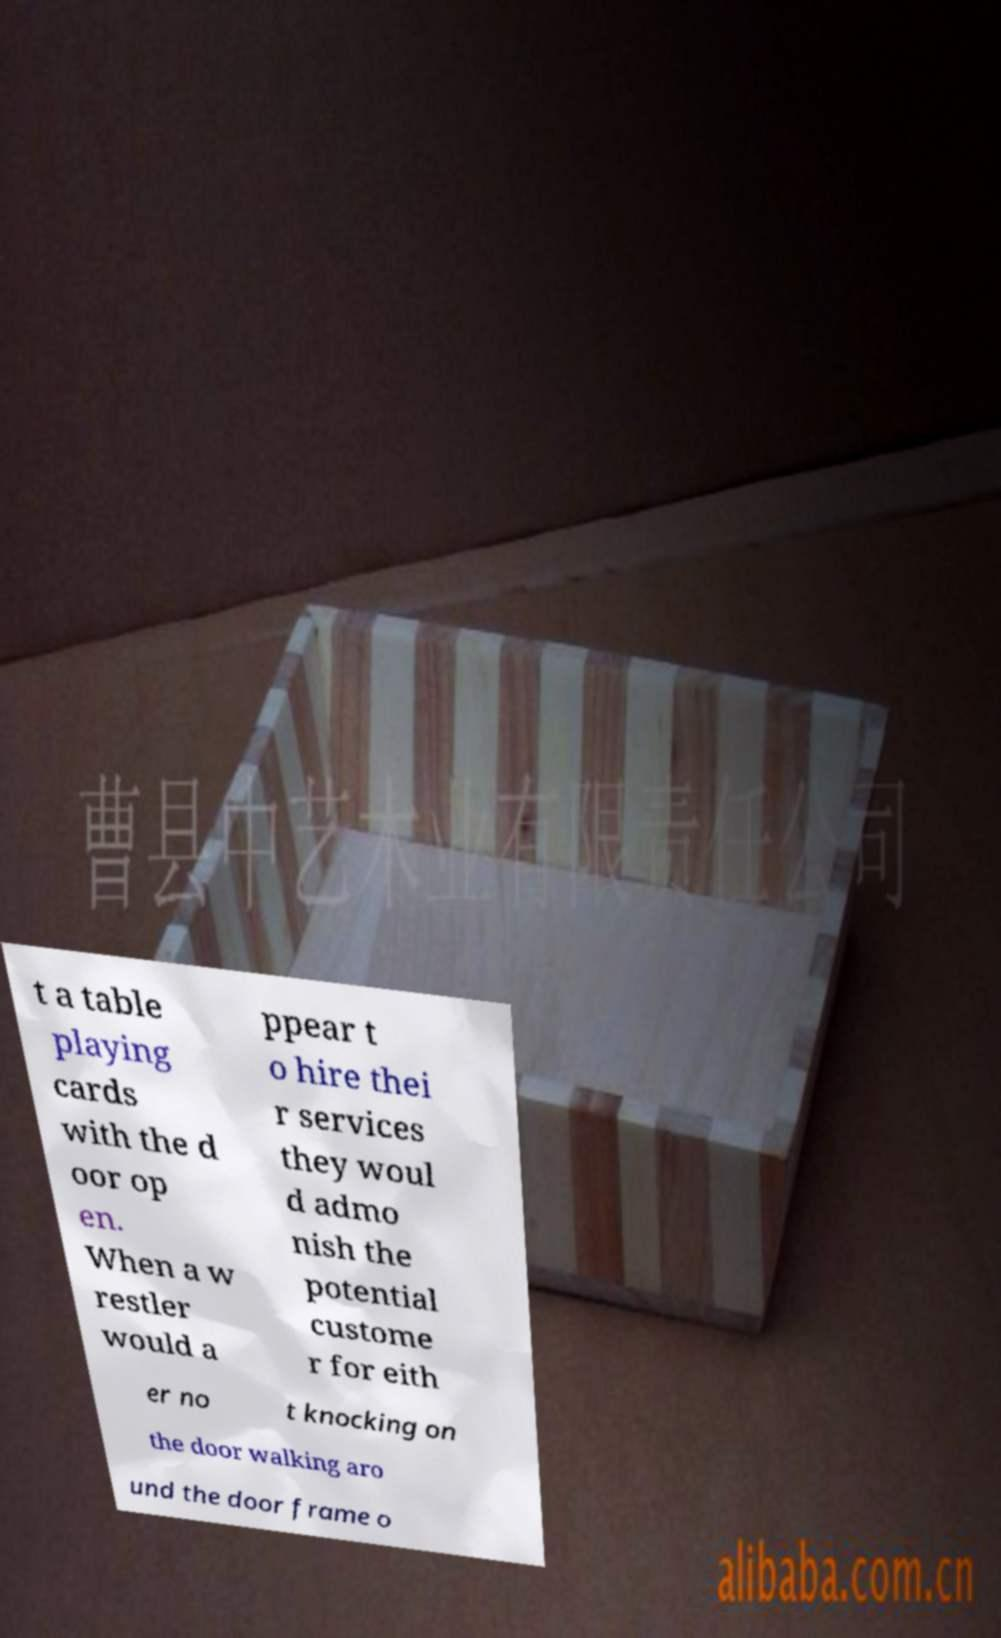For documentation purposes, I need the text within this image transcribed. Could you provide that? t a table playing cards with the d oor op en. When a w restler would a ppear t o hire thei r services they woul d admo nish the potential custome r for eith er no t knocking on the door walking aro und the door frame o 